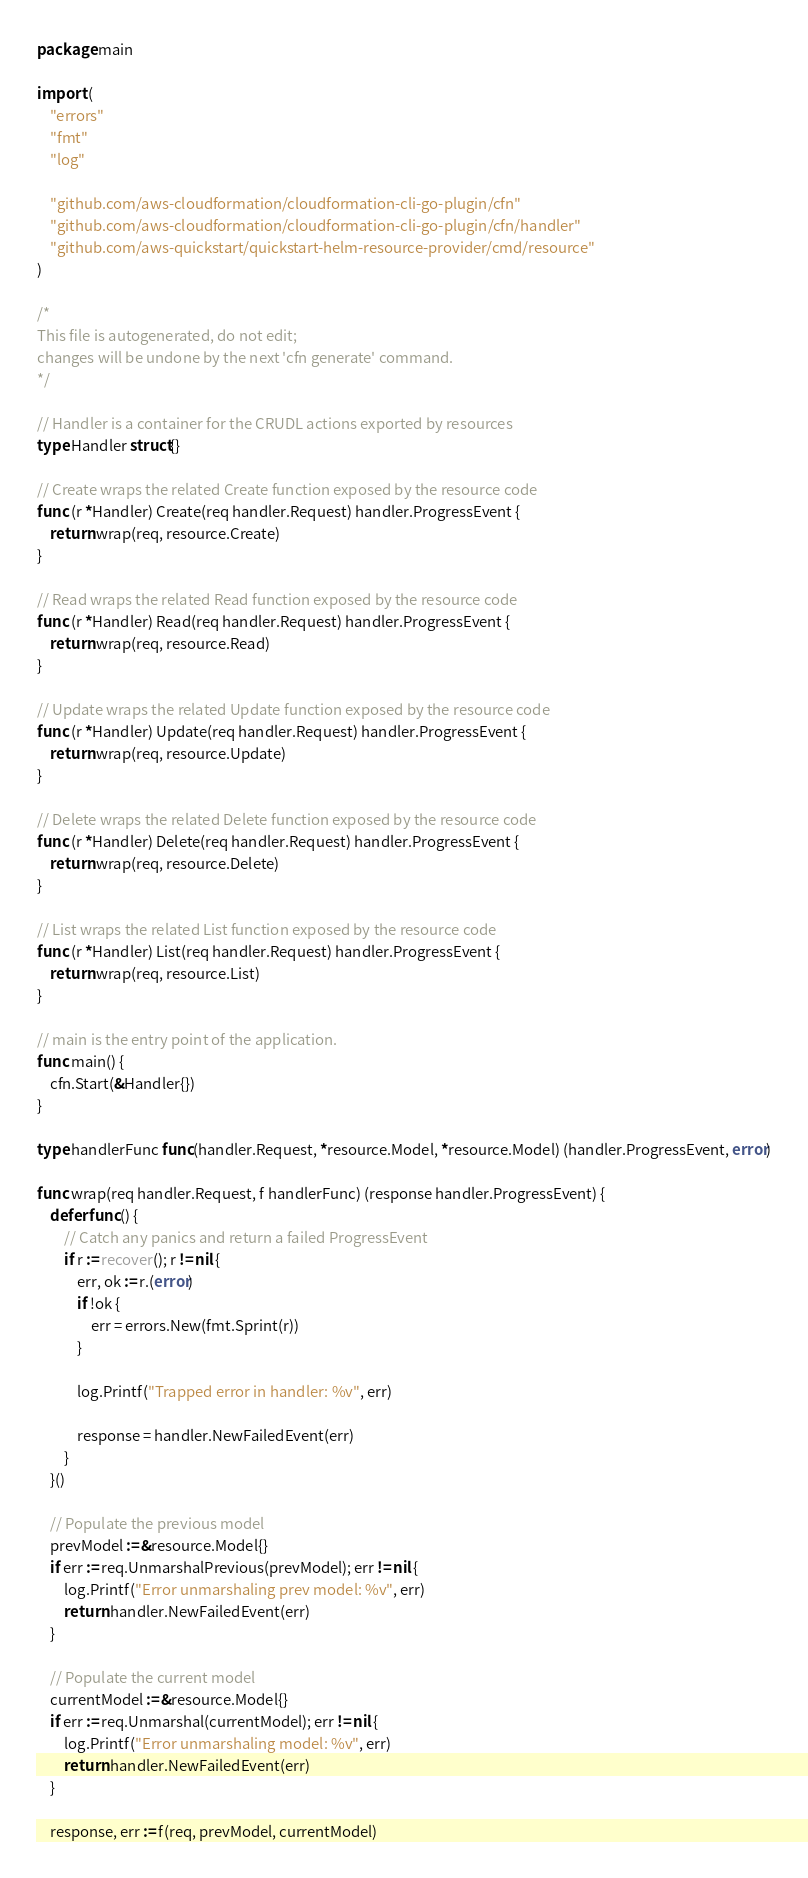Convert code to text. <code><loc_0><loc_0><loc_500><loc_500><_Go_>package main

import (
	"errors"
	"fmt"
	"log"

	"github.com/aws-cloudformation/cloudformation-cli-go-plugin/cfn"
	"github.com/aws-cloudformation/cloudformation-cli-go-plugin/cfn/handler"
	"github.com/aws-quickstart/quickstart-helm-resource-provider/cmd/resource"
)

/*
This file is autogenerated, do not edit;
changes will be undone by the next 'cfn generate' command.
*/

// Handler is a container for the CRUDL actions exported by resources
type Handler struct{}

// Create wraps the related Create function exposed by the resource code
func (r *Handler) Create(req handler.Request) handler.ProgressEvent {
	return wrap(req, resource.Create)
}

// Read wraps the related Read function exposed by the resource code
func (r *Handler) Read(req handler.Request) handler.ProgressEvent {
	return wrap(req, resource.Read)
}

// Update wraps the related Update function exposed by the resource code
func (r *Handler) Update(req handler.Request) handler.ProgressEvent {
	return wrap(req, resource.Update)
}

// Delete wraps the related Delete function exposed by the resource code
func (r *Handler) Delete(req handler.Request) handler.ProgressEvent {
	return wrap(req, resource.Delete)
}

// List wraps the related List function exposed by the resource code
func (r *Handler) List(req handler.Request) handler.ProgressEvent {
	return wrap(req, resource.List)
}

// main is the entry point of the application.
func main() {
	cfn.Start(&Handler{})
}

type handlerFunc func(handler.Request, *resource.Model, *resource.Model) (handler.ProgressEvent, error)

func wrap(req handler.Request, f handlerFunc) (response handler.ProgressEvent) {
	defer func() {
		// Catch any panics and return a failed ProgressEvent
		if r := recover(); r != nil {
			err, ok := r.(error)
			if !ok {
				err = errors.New(fmt.Sprint(r))
			}

			log.Printf("Trapped error in handler: %v", err)

			response = handler.NewFailedEvent(err)
		}
	}()

	// Populate the previous model
	prevModel := &resource.Model{}
	if err := req.UnmarshalPrevious(prevModel); err != nil {
		log.Printf("Error unmarshaling prev model: %v", err)
		return handler.NewFailedEvent(err)
	}

	// Populate the current model
	currentModel := &resource.Model{}
	if err := req.Unmarshal(currentModel); err != nil {
		log.Printf("Error unmarshaling model: %v", err)
		return handler.NewFailedEvent(err)
	}

	response, err := f(req, prevModel, currentModel)</code> 